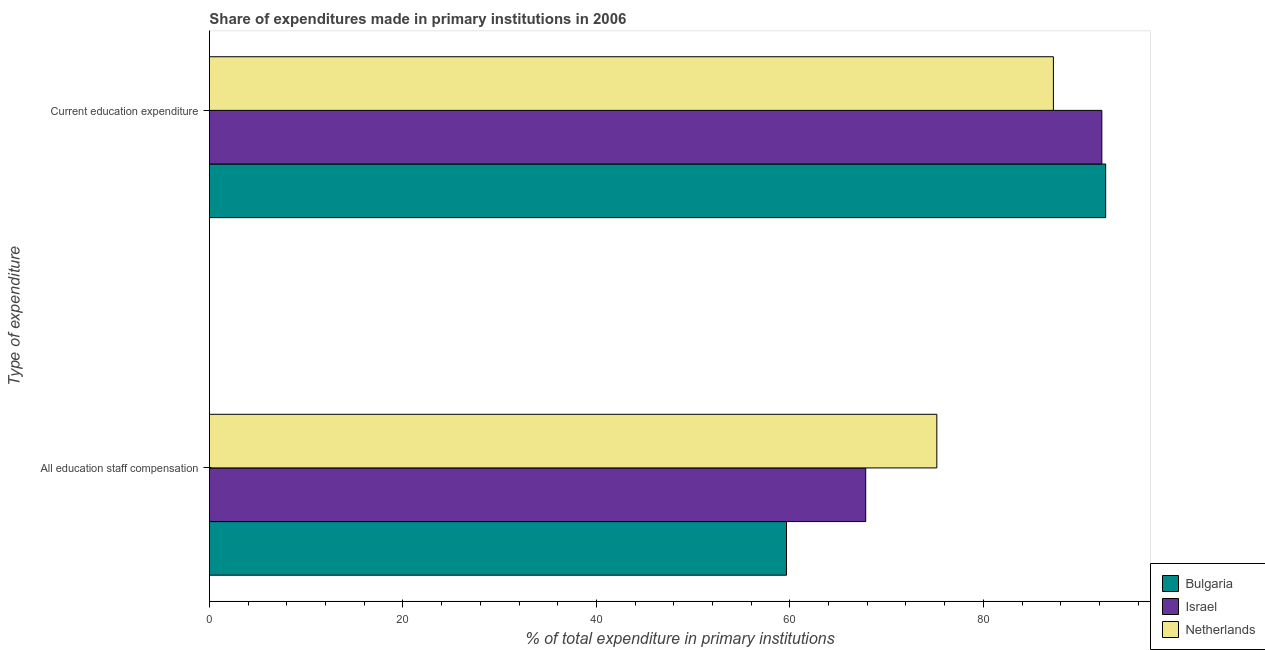Are the number of bars per tick equal to the number of legend labels?
Give a very brief answer. Yes. What is the label of the 1st group of bars from the top?
Your answer should be very brief. Current education expenditure. What is the expenditure in education in Netherlands?
Your answer should be compact. 87.24. Across all countries, what is the maximum expenditure in education?
Your response must be concise. 92.64. Across all countries, what is the minimum expenditure in education?
Your answer should be compact. 87.24. In which country was the expenditure in staff compensation maximum?
Your response must be concise. Netherlands. What is the total expenditure in education in the graph?
Offer a terse response. 272.13. What is the difference between the expenditure in education in Netherlands and that in Israel?
Provide a short and direct response. -5.01. What is the difference between the expenditure in education in Netherlands and the expenditure in staff compensation in Israel?
Keep it short and to the point. 19.4. What is the average expenditure in staff compensation per country?
Offer a very short reply. 67.56. What is the difference between the expenditure in staff compensation and expenditure in education in Netherlands?
Offer a terse response. -12.05. What is the ratio of the expenditure in education in Bulgaria to that in Netherlands?
Offer a very short reply. 1.06. Is the expenditure in education in Netherlands less than that in Israel?
Keep it short and to the point. Yes. What does the 1st bar from the top in Current education expenditure represents?
Your answer should be compact. Netherlands. How many bars are there?
Ensure brevity in your answer.  6. Are all the bars in the graph horizontal?
Provide a short and direct response. Yes. Does the graph contain any zero values?
Ensure brevity in your answer.  No. Where does the legend appear in the graph?
Provide a succinct answer. Bottom right. How many legend labels are there?
Your response must be concise. 3. What is the title of the graph?
Offer a terse response. Share of expenditures made in primary institutions in 2006. Does "Liberia" appear as one of the legend labels in the graph?
Provide a short and direct response. No. What is the label or title of the X-axis?
Give a very brief answer. % of total expenditure in primary institutions. What is the label or title of the Y-axis?
Your response must be concise. Type of expenditure. What is the % of total expenditure in primary institutions of Bulgaria in All education staff compensation?
Give a very brief answer. 59.65. What is the % of total expenditure in primary institutions in Israel in All education staff compensation?
Your answer should be very brief. 67.84. What is the % of total expenditure in primary institutions of Netherlands in All education staff compensation?
Your answer should be very brief. 75.19. What is the % of total expenditure in primary institutions of Bulgaria in Current education expenditure?
Your answer should be very brief. 92.64. What is the % of total expenditure in primary institutions in Israel in Current education expenditure?
Provide a succinct answer. 92.25. What is the % of total expenditure in primary institutions in Netherlands in Current education expenditure?
Provide a succinct answer. 87.24. Across all Type of expenditure, what is the maximum % of total expenditure in primary institutions of Bulgaria?
Your response must be concise. 92.64. Across all Type of expenditure, what is the maximum % of total expenditure in primary institutions in Israel?
Ensure brevity in your answer.  92.25. Across all Type of expenditure, what is the maximum % of total expenditure in primary institutions of Netherlands?
Make the answer very short. 87.24. Across all Type of expenditure, what is the minimum % of total expenditure in primary institutions in Bulgaria?
Give a very brief answer. 59.65. Across all Type of expenditure, what is the minimum % of total expenditure in primary institutions of Israel?
Offer a very short reply. 67.84. Across all Type of expenditure, what is the minimum % of total expenditure in primary institutions of Netherlands?
Provide a succinct answer. 75.19. What is the total % of total expenditure in primary institutions of Bulgaria in the graph?
Offer a very short reply. 152.29. What is the total % of total expenditure in primary institutions in Israel in the graph?
Give a very brief answer. 160.08. What is the total % of total expenditure in primary institutions of Netherlands in the graph?
Offer a terse response. 162.43. What is the difference between the % of total expenditure in primary institutions of Bulgaria in All education staff compensation and that in Current education expenditure?
Offer a terse response. -32.99. What is the difference between the % of total expenditure in primary institutions in Israel in All education staff compensation and that in Current education expenditure?
Offer a terse response. -24.41. What is the difference between the % of total expenditure in primary institutions of Netherlands in All education staff compensation and that in Current education expenditure?
Provide a succinct answer. -12.05. What is the difference between the % of total expenditure in primary institutions in Bulgaria in All education staff compensation and the % of total expenditure in primary institutions in Israel in Current education expenditure?
Offer a very short reply. -32.59. What is the difference between the % of total expenditure in primary institutions of Bulgaria in All education staff compensation and the % of total expenditure in primary institutions of Netherlands in Current education expenditure?
Offer a terse response. -27.59. What is the difference between the % of total expenditure in primary institutions in Israel in All education staff compensation and the % of total expenditure in primary institutions in Netherlands in Current education expenditure?
Keep it short and to the point. -19.4. What is the average % of total expenditure in primary institutions in Bulgaria per Type of expenditure?
Give a very brief answer. 76.15. What is the average % of total expenditure in primary institutions of Israel per Type of expenditure?
Offer a very short reply. 80.04. What is the average % of total expenditure in primary institutions of Netherlands per Type of expenditure?
Provide a short and direct response. 81.21. What is the difference between the % of total expenditure in primary institutions of Bulgaria and % of total expenditure in primary institutions of Israel in All education staff compensation?
Provide a short and direct response. -8.18. What is the difference between the % of total expenditure in primary institutions in Bulgaria and % of total expenditure in primary institutions in Netherlands in All education staff compensation?
Provide a succinct answer. -15.54. What is the difference between the % of total expenditure in primary institutions in Israel and % of total expenditure in primary institutions in Netherlands in All education staff compensation?
Provide a short and direct response. -7.35. What is the difference between the % of total expenditure in primary institutions in Bulgaria and % of total expenditure in primary institutions in Israel in Current education expenditure?
Your answer should be compact. 0.4. What is the difference between the % of total expenditure in primary institutions in Bulgaria and % of total expenditure in primary institutions in Netherlands in Current education expenditure?
Make the answer very short. 5.4. What is the difference between the % of total expenditure in primary institutions of Israel and % of total expenditure in primary institutions of Netherlands in Current education expenditure?
Your answer should be compact. 5.01. What is the ratio of the % of total expenditure in primary institutions in Bulgaria in All education staff compensation to that in Current education expenditure?
Your answer should be compact. 0.64. What is the ratio of the % of total expenditure in primary institutions of Israel in All education staff compensation to that in Current education expenditure?
Provide a succinct answer. 0.74. What is the ratio of the % of total expenditure in primary institutions of Netherlands in All education staff compensation to that in Current education expenditure?
Your answer should be very brief. 0.86. What is the difference between the highest and the second highest % of total expenditure in primary institutions in Bulgaria?
Provide a succinct answer. 32.99. What is the difference between the highest and the second highest % of total expenditure in primary institutions in Israel?
Make the answer very short. 24.41. What is the difference between the highest and the second highest % of total expenditure in primary institutions of Netherlands?
Your response must be concise. 12.05. What is the difference between the highest and the lowest % of total expenditure in primary institutions in Bulgaria?
Provide a short and direct response. 32.99. What is the difference between the highest and the lowest % of total expenditure in primary institutions of Israel?
Offer a terse response. 24.41. What is the difference between the highest and the lowest % of total expenditure in primary institutions in Netherlands?
Ensure brevity in your answer.  12.05. 